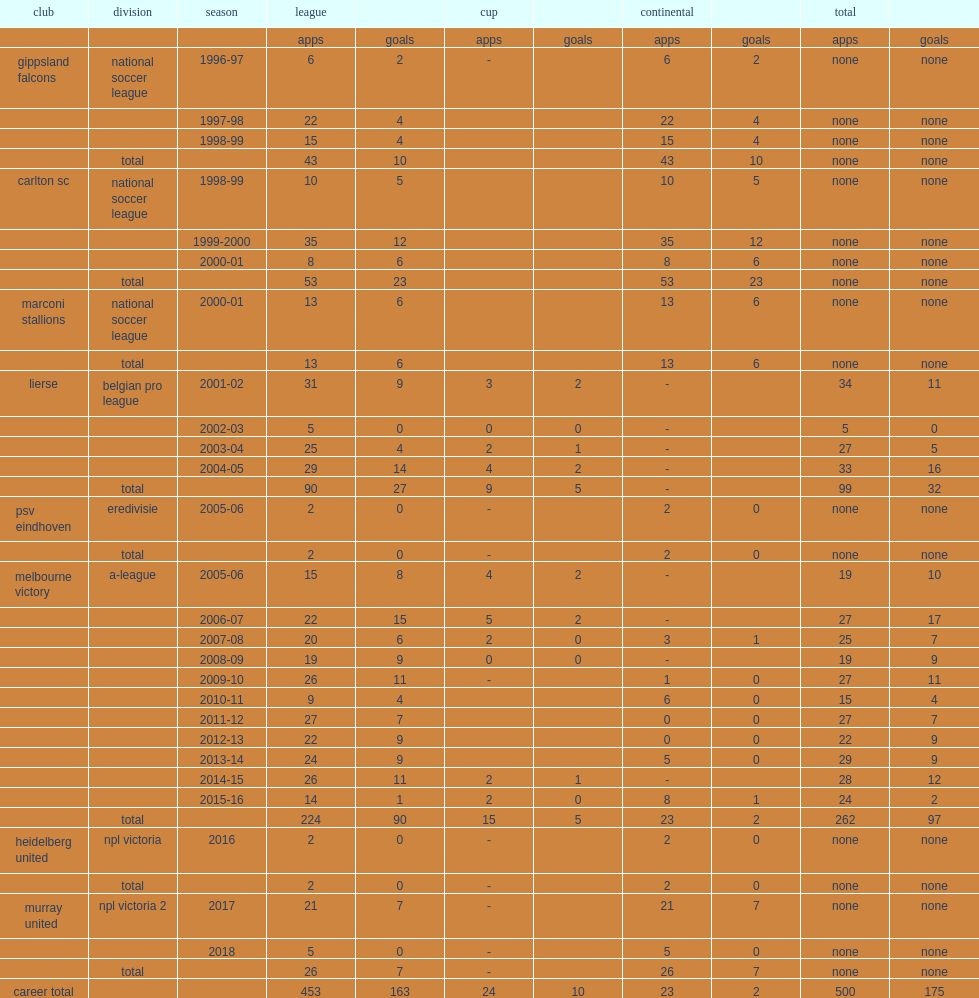In which season did archie thompson sign the gippsland falcons in the national soccer league? 1996-97. 